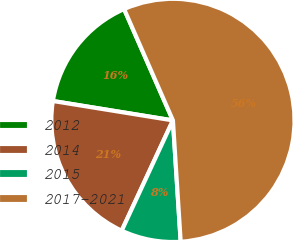<chart> <loc_0><loc_0><loc_500><loc_500><pie_chart><fcel>2012<fcel>2014<fcel>2015<fcel>2017-2021<nl><fcel>15.87%<fcel>20.63%<fcel>7.94%<fcel>55.56%<nl></chart> 